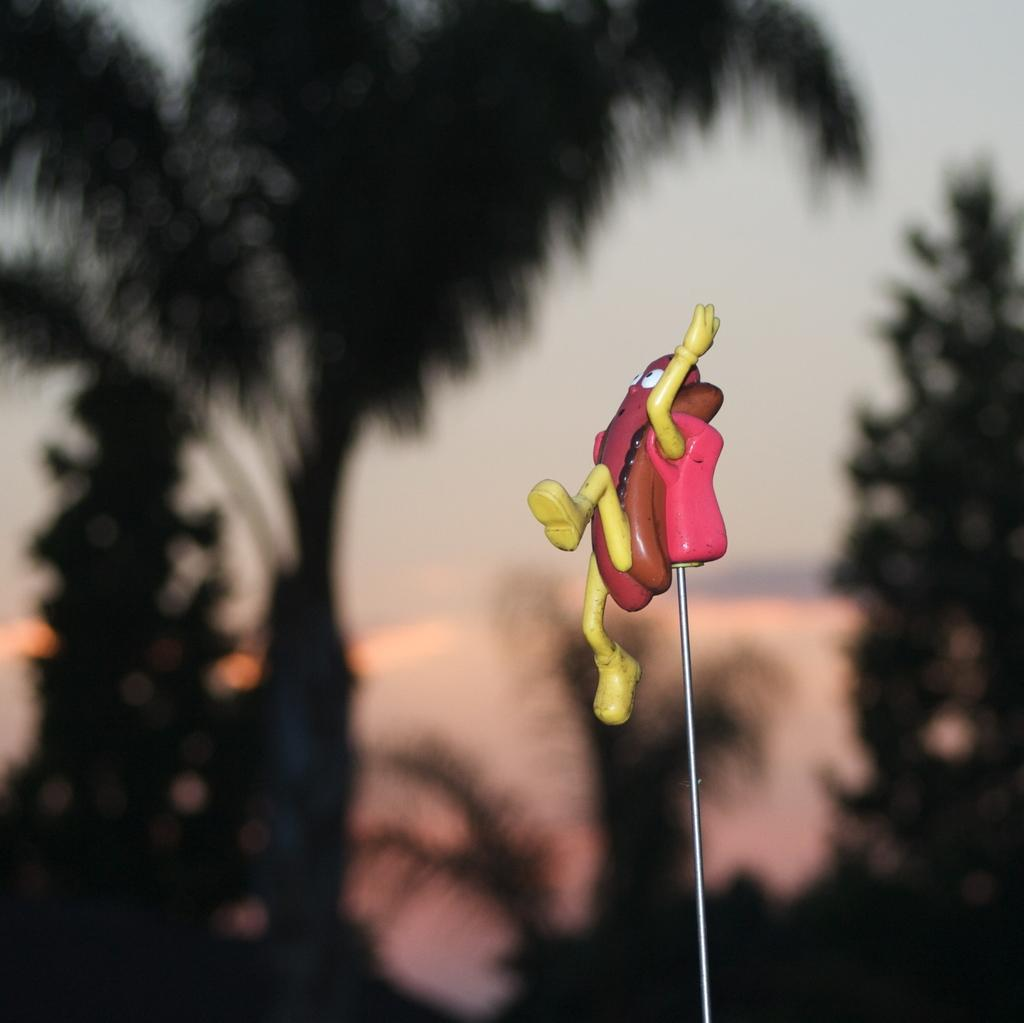What object can be seen in the image? There is a toy in the image. What can be seen in the distance in the image? There are trees in the background of the image. What part of the natural environment is visible in the image? The sky is visible in the background of the image. How is the background of the image depicted? The background of the image is blurred. What type of wax can be seen melting in the image? There is no wax present in the image. 